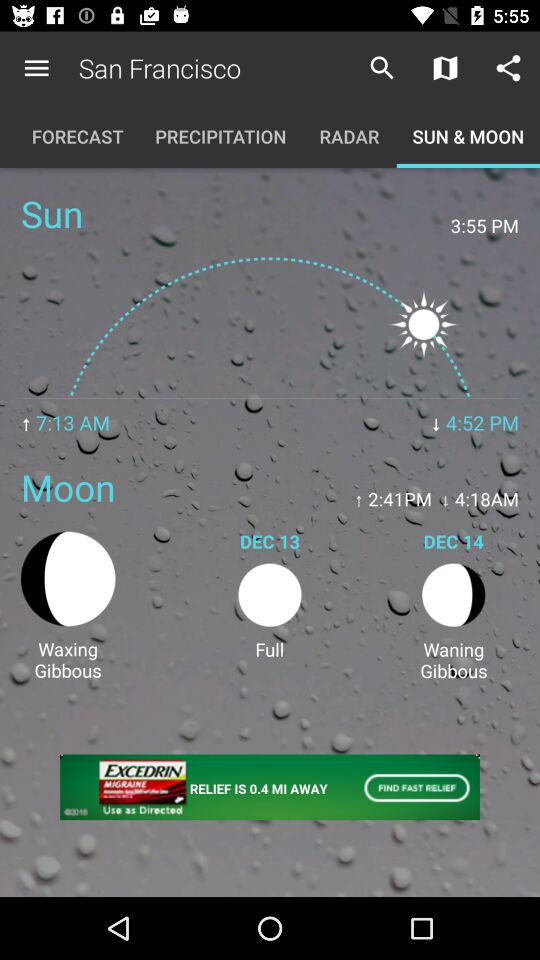When will the waning gibbous phase of the moon begin? The waning gibbous phase of the moon will begin on December 14. 